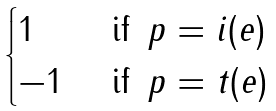Convert formula to latex. <formula><loc_0><loc_0><loc_500><loc_500>\begin{cases} 1 & \text { if } \, p = i ( e ) \\ - 1 & \text { if } \, p = t ( e ) \end{cases}</formula> 